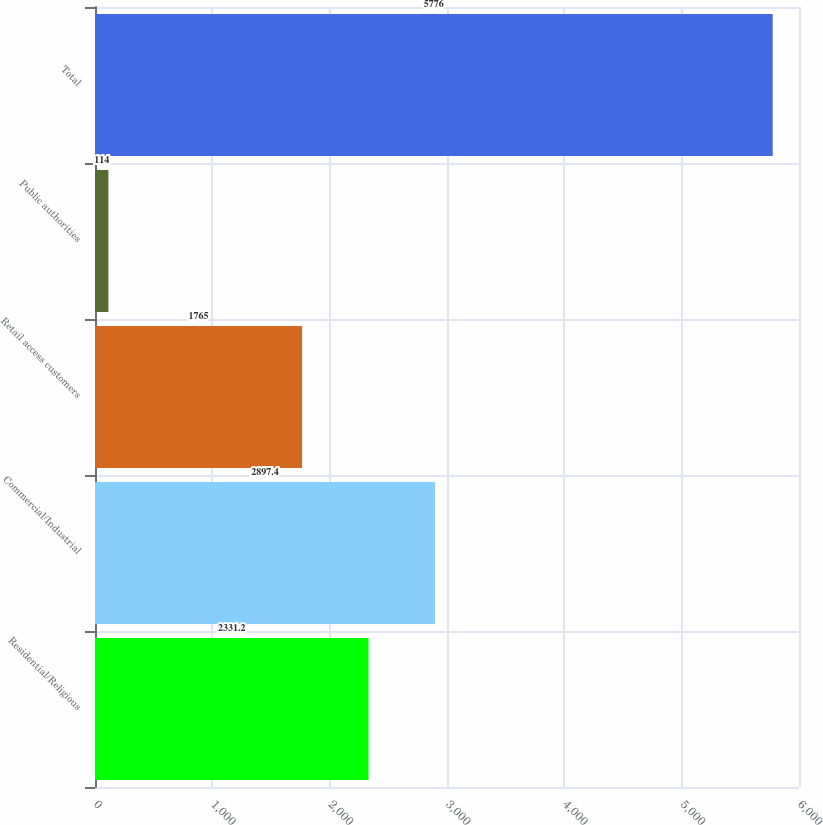<chart> <loc_0><loc_0><loc_500><loc_500><bar_chart><fcel>Residential/Religious<fcel>Commercial/Industrial<fcel>Retail access customers<fcel>Public authorities<fcel>Total<nl><fcel>2331.2<fcel>2897.4<fcel>1765<fcel>114<fcel>5776<nl></chart> 